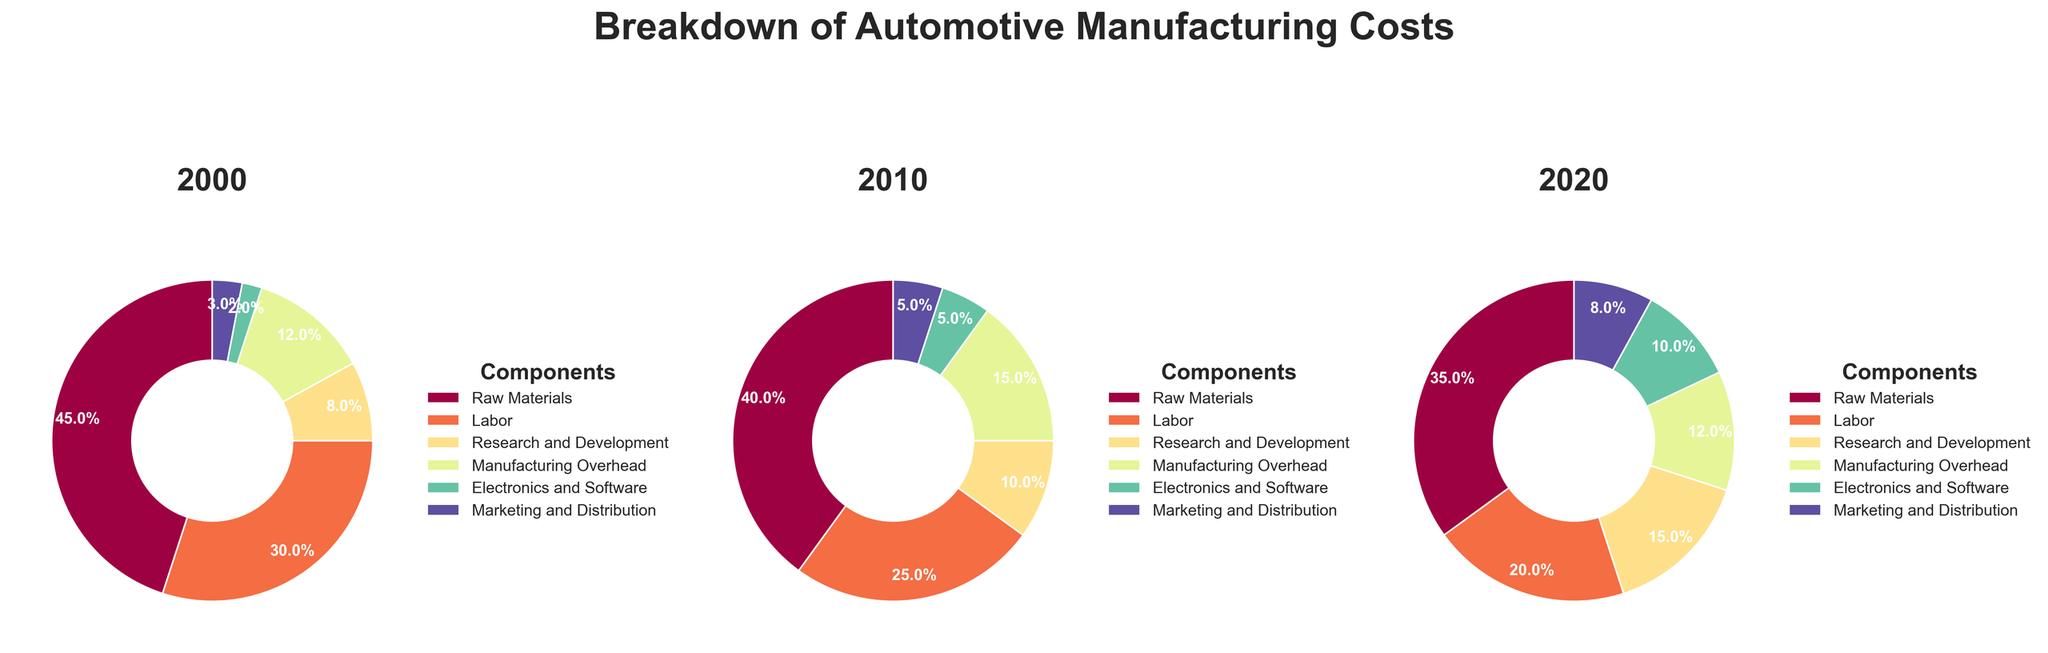What are the percentages of Raw Materials in 2000, 2010, and 2020 respectively? Look at each pie chart for the years 2000, 2010, and 2020, and find the segment labeled 'Raw Materials'. Note the percentage associated with each segment.
Answer: 45%, 40%, 35% How has the percentage of Labor costs changed from 2000 to 2020? Compare the percentage of the Labor component in the 2000 pie chart with the 2020 pie chart. Specifically, subtract the percentage from 2020 from the percentage in 2000.
Answer: Decreased by 10% Which component has the smallest percentage in 2000, and what is the percentage? Look at the pie chart for 2000 and identify the smallest segment by percentage.
Answer: Marketing and Distribution, 3% What is the total percentage of Electronics and Software combined over the years 2000, 2010, and 2020? Sum the percentages of the Electronics and Software component from the pie charts for 2000, 2010, and 2020. The percentages to sum are 2%, 5%, and 10%.
Answer: 17% Which year has the highest percentage for Research and Development, and what is the percentage? Look at the segments for Research and Development in each of the pie charts and compare the percentages. Identify the highest percentage among them.
Answer: 2020, 15% What is the difference in the percentage of Marketing and Distribution between 2000 and 2020? Find the percentage for Marketing and Distribution in both the 2000 and 2020 pie charts. Subtract the 2000 percentage from the 2020 percentage.
Answer: Increased by 5% Which component's percentage has not changed from 2000 to 2020? Compare the components in both the 2000 and 2020 pie charts, noting any components with identical percentages in both years.
Answer: Manufacturing Overhead, 12% How does the percentage of Electronics and Software in 2010 compare to 2020? In the pie charts for 2010 and 2020, find the segment for Electronics and Software and compare their percentages.
Answer: Doubled, from 5% to 10% What is the total percentage accounted for by Raw Materials and Labor in 2010? Add the percentages for Raw Materials and Labor components from the 2010 pie chart. The percentages are 40% and 25%, respectively.
Answer: 65% How has the percentage of Research and Development changed from 2010 to 2020? Compare the Research and Development segment percentages from the 2010 and 2020 pie charts. Subtract the percentage from 2010 from the percentage in 2020.
Answer: Increased by 5% 